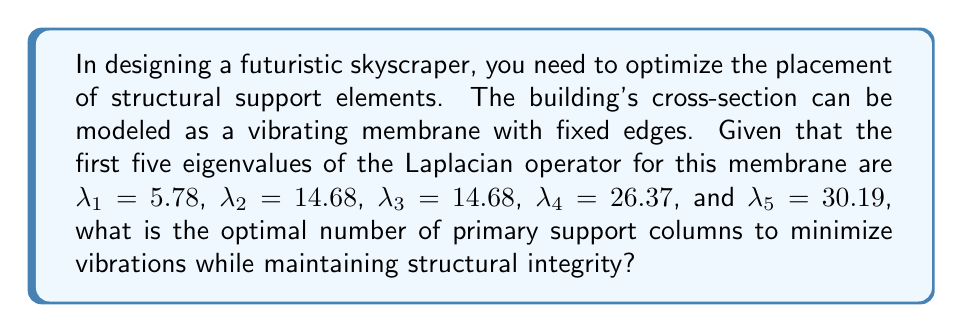Can you solve this math problem? To solve this problem, we need to apply spectral theory and eigenvalue analysis to the design of the skyscraper's structural support system. Here's a step-by-step explanation:

1. The eigenvalues of the Laplacian operator represent the natural frequencies of vibration for the building's cross-section.

2. In structural engineering, we typically want to avoid resonance with the first few modes of vibration, as these are the most likely to be excited by external forces (wind, earthquakes, etc.).

3. The multiplicity of eigenvalues provides information about the symmetry of the structure. We notice that $\lambda_2 = \lambda_3$, which suggests a symmetrical shape (likely square or circular).

4. The gap between consecutive eigenvalues is important:
   $\lambda_2 - \lambda_1 = 8.90$
   $\lambda_4 - \lambda_3 = 11.69$
   $\lambda_5 - \lambda_4 = 3.82$

5. The largest gap is between $\lambda_3$ and $\lambda_4$, indicating a natural separation between the lower and higher modes of vibration.

6. To minimize vibrations, we want to place supports at the nodal lines of the lower modes while reinforcing the structure against the higher modes.

7. The optimal number of primary support columns typically corresponds to the number of eigenvalues before the largest gap, plus one (to account for the fundamental mode).

8. In this case, we have 3 eigenvalues before the largest gap ($\lambda_1$, $\lambda_2$, $\lambda_3$), so the optimal number of primary support columns would be 4.

9. This configuration allows us to place columns at the nodal lines of the first three modes, effectively damping these lower frequency vibrations while providing sufficient support for the higher modes.

This solution balances the need to minimize vibrations with the structural integrity requirements of the futuristic skyscraper.
Answer: The optimal number of primary support columns is 4. 